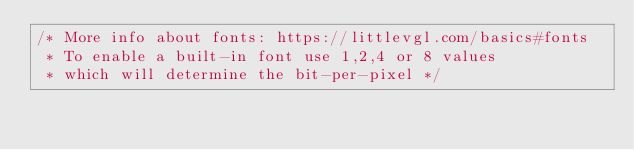<code> <loc_0><loc_0><loc_500><loc_500><_C_>/* More info about fonts: https://littlevgl.com/basics#fonts
 * To enable a built-in font use 1,2,4 or 8 values
 * which will determine the bit-per-pixel */</code> 